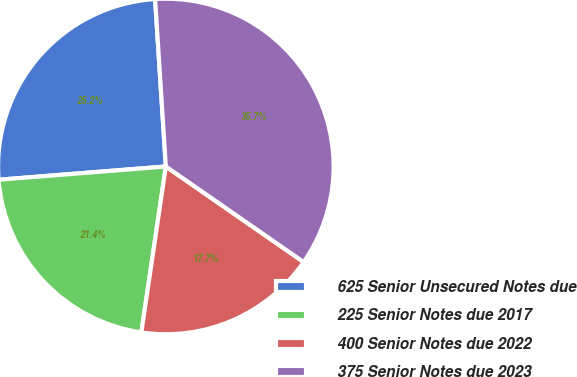Convert chart to OTSL. <chart><loc_0><loc_0><loc_500><loc_500><pie_chart><fcel>625 Senior Unsecured Notes due<fcel>225 Senior Notes due 2017<fcel>400 Senior Notes due 2022<fcel>375 Senior Notes due 2023<nl><fcel>25.24%<fcel>21.41%<fcel>17.68%<fcel>35.67%<nl></chart> 